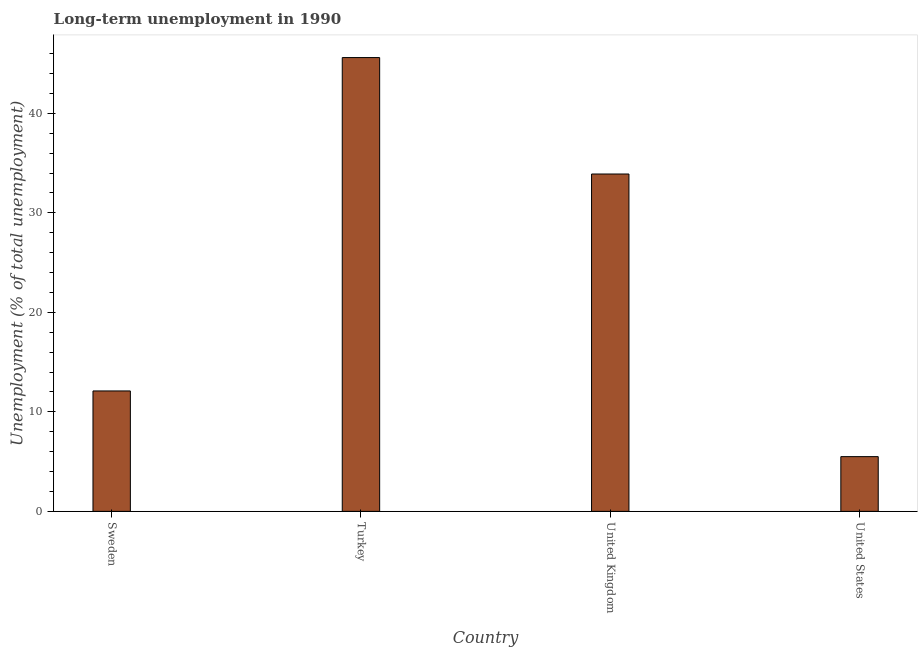Does the graph contain any zero values?
Your answer should be very brief. No. What is the title of the graph?
Offer a very short reply. Long-term unemployment in 1990. What is the label or title of the X-axis?
Make the answer very short. Country. What is the label or title of the Y-axis?
Provide a short and direct response. Unemployment (% of total unemployment). What is the long-term unemployment in United Kingdom?
Provide a succinct answer. 33.9. Across all countries, what is the maximum long-term unemployment?
Offer a terse response. 45.6. What is the sum of the long-term unemployment?
Keep it short and to the point. 97.1. What is the average long-term unemployment per country?
Provide a succinct answer. 24.27. What is the median long-term unemployment?
Provide a short and direct response. 23. In how many countries, is the long-term unemployment greater than 18 %?
Provide a succinct answer. 2. What is the ratio of the long-term unemployment in Sweden to that in United Kingdom?
Offer a very short reply. 0.36. Is the long-term unemployment in Sweden less than that in United Kingdom?
Offer a terse response. Yes. Is the difference between the long-term unemployment in Turkey and United States greater than the difference between any two countries?
Provide a succinct answer. Yes. What is the difference between the highest and the second highest long-term unemployment?
Offer a very short reply. 11.7. Is the sum of the long-term unemployment in United Kingdom and United States greater than the maximum long-term unemployment across all countries?
Your answer should be compact. No. What is the difference between the highest and the lowest long-term unemployment?
Ensure brevity in your answer.  40.1. In how many countries, is the long-term unemployment greater than the average long-term unemployment taken over all countries?
Give a very brief answer. 2. Are all the bars in the graph horizontal?
Provide a short and direct response. No. What is the difference between two consecutive major ticks on the Y-axis?
Keep it short and to the point. 10. What is the Unemployment (% of total unemployment) of Sweden?
Provide a short and direct response. 12.1. What is the Unemployment (% of total unemployment) in Turkey?
Keep it short and to the point. 45.6. What is the Unemployment (% of total unemployment) in United Kingdom?
Make the answer very short. 33.9. What is the Unemployment (% of total unemployment) in United States?
Provide a succinct answer. 5.5. What is the difference between the Unemployment (% of total unemployment) in Sweden and Turkey?
Give a very brief answer. -33.5. What is the difference between the Unemployment (% of total unemployment) in Sweden and United Kingdom?
Keep it short and to the point. -21.8. What is the difference between the Unemployment (% of total unemployment) in Sweden and United States?
Offer a very short reply. 6.6. What is the difference between the Unemployment (% of total unemployment) in Turkey and United States?
Provide a short and direct response. 40.1. What is the difference between the Unemployment (% of total unemployment) in United Kingdom and United States?
Provide a short and direct response. 28.4. What is the ratio of the Unemployment (% of total unemployment) in Sweden to that in Turkey?
Provide a short and direct response. 0.27. What is the ratio of the Unemployment (% of total unemployment) in Sweden to that in United Kingdom?
Provide a short and direct response. 0.36. What is the ratio of the Unemployment (% of total unemployment) in Turkey to that in United Kingdom?
Give a very brief answer. 1.34. What is the ratio of the Unemployment (% of total unemployment) in Turkey to that in United States?
Make the answer very short. 8.29. What is the ratio of the Unemployment (% of total unemployment) in United Kingdom to that in United States?
Your answer should be very brief. 6.16. 